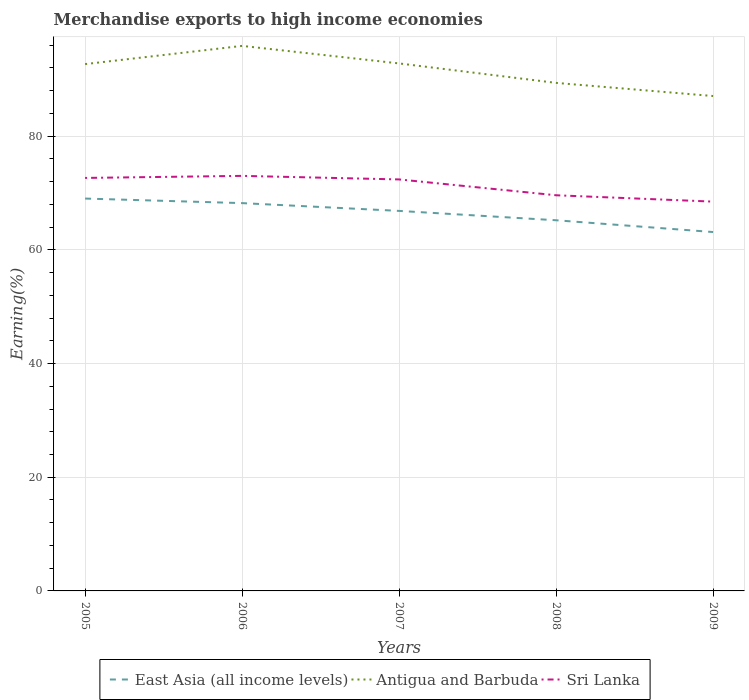Does the line corresponding to East Asia (all income levels) intersect with the line corresponding to Antigua and Barbuda?
Ensure brevity in your answer.  No. Across all years, what is the maximum percentage of amount earned from merchandise exports in East Asia (all income levels)?
Your answer should be compact. 63.13. In which year was the percentage of amount earned from merchandise exports in Antigua and Barbuda maximum?
Your answer should be very brief. 2009. What is the total percentage of amount earned from merchandise exports in Sri Lanka in the graph?
Provide a succinct answer. 4.17. What is the difference between the highest and the second highest percentage of amount earned from merchandise exports in Sri Lanka?
Provide a succinct answer. 4.53. What is the difference between the highest and the lowest percentage of amount earned from merchandise exports in Antigua and Barbuda?
Give a very brief answer. 3. Is the percentage of amount earned from merchandise exports in Sri Lanka strictly greater than the percentage of amount earned from merchandise exports in Antigua and Barbuda over the years?
Provide a succinct answer. Yes. How many years are there in the graph?
Keep it short and to the point. 5. Are the values on the major ticks of Y-axis written in scientific E-notation?
Offer a very short reply. No. How are the legend labels stacked?
Keep it short and to the point. Horizontal. What is the title of the graph?
Ensure brevity in your answer.  Merchandise exports to high income economies. What is the label or title of the X-axis?
Make the answer very short. Years. What is the label or title of the Y-axis?
Ensure brevity in your answer.  Earning(%). What is the Earning(%) in East Asia (all income levels) in 2005?
Offer a terse response. 69.02. What is the Earning(%) in Antigua and Barbuda in 2005?
Provide a succinct answer. 92.67. What is the Earning(%) in Sri Lanka in 2005?
Your response must be concise. 72.65. What is the Earning(%) in East Asia (all income levels) in 2006?
Offer a terse response. 68.22. What is the Earning(%) in Antigua and Barbuda in 2006?
Your answer should be very brief. 95.88. What is the Earning(%) in Sri Lanka in 2006?
Provide a succinct answer. 73.01. What is the Earning(%) in East Asia (all income levels) in 2007?
Keep it short and to the point. 66.85. What is the Earning(%) in Antigua and Barbuda in 2007?
Your answer should be very brief. 92.79. What is the Earning(%) in Sri Lanka in 2007?
Provide a short and direct response. 72.39. What is the Earning(%) of East Asia (all income levels) in 2008?
Give a very brief answer. 65.2. What is the Earning(%) of Antigua and Barbuda in 2008?
Keep it short and to the point. 89.37. What is the Earning(%) of Sri Lanka in 2008?
Make the answer very short. 69.6. What is the Earning(%) in East Asia (all income levels) in 2009?
Offer a terse response. 63.13. What is the Earning(%) in Antigua and Barbuda in 2009?
Offer a very short reply. 87.06. What is the Earning(%) of Sri Lanka in 2009?
Offer a terse response. 68.48. Across all years, what is the maximum Earning(%) in East Asia (all income levels)?
Your response must be concise. 69.02. Across all years, what is the maximum Earning(%) of Antigua and Barbuda?
Provide a short and direct response. 95.88. Across all years, what is the maximum Earning(%) in Sri Lanka?
Your answer should be very brief. 73.01. Across all years, what is the minimum Earning(%) in East Asia (all income levels)?
Ensure brevity in your answer.  63.13. Across all years, what is the minimum Earning(%) of Antigua and Barbuda?
Your response must be concise. 87.06. Across all years, what is the minimum Earning(%) of Sri Lanka?
Make the answer very short. 68.48. What is the total Earning(%) in East Asia (all income levels) in the graph?
Keep it short and to the point. 332.43. What is the total Earning(%) of Antigua and Barbuda in the graph?
Your answer should be very brief. 457.77. What is the total Earning(%) in Sri Lanka in the graph?
Your answer should be compact. 356.13. What is the difference between the Earning(%) of East Asia (all income levels) in 2005 and that in 2006?
Ensure brevity in your answer.  0.8. What is the difference between the Earning(%) in Antigua and Barbuda in 2005 and that in 2006?
Give a very brief answer. -3.21. What is the difference between the Earning(%) of Sri Lanka in 2005 and that in 2006?
Offer a terse response. -0.36. What is the difference between the Earning(%) of East Asia (all income levels) in 2005 and that in 2007?
Ensure brevity in your answer.  2.17. What is the difference between the Earning(%) of Antigua and Barbuda in 2005 and that in 2007?
Make the answer very short. -0.12. What is the difference between the Earning(%) of Sri Lanka in 2005 and that in 2007?
Provide a succinct answer. 0.26. What is the difference between the Earning(%) in East Asia (all income levels) in 2005 and that in 2008?
Your answer should be very brief. 3.82. What is the difference between the Earning(%) of Antigua and Barbuda in 2005 and that in 2008?
Ensure brevity in your answer.  3.3. What is the difference between the Earning(%) of Sri Lanka in 2005 and that in 2008?
Your answer should be very brief. 3.05. What is the difference between the Earning(%) in East Asia (all income levels) in 2005 and that in 2009?
Make the answer very short. 5.89. What is the difference between the Earning(%) of Antigua and Barbuda in 2005 and that in 2009?
Your answer should be very brief. 5.62. What is the difference between the Earning(%) of Sri Lanka in 2005 and that in 2009?
Your response must be concise. 4.17. What is the difference between the Earning(%) in East Asia (all income levels) in 2006 and that in 2007?
Make the answer very short. 1.37. What is the difference between the Earning(%) in Antigua and Barbuda in 2006 and that in 2007?
Your answer should be compact. 3.09. What is the difference between the Earning(%) in Sri Lanka in 2006 and that in 2007?
Make the answer very short. 0.63. What is the difference between the Earning(%) in East Asia (all income levels) in 2006 and that in 2008?
Your answer should be compact. 3.02. What is the difference between the Earning(%) in Antigua and Barbuda in 2006 and that in 2008?
Give a very brief answer. 6.51. What is the difference between the Earning(%) in Sri Lanka in 2006 and that in 2008?
Offer a terse response. 3.41. What is the difference between the Earning(%) in East Asia (all income levels) in 2006 and that in 2009?
Your answer should be compact. 5.09. What is the difference between the Earning(%) in Antigua and Barbuda in 2006 and that in 2009?
Offer a very short reply. 8.82. What is the difference between the Earning(%) of Sri Lanka in 2006 and that in 2009?
Offer a very short reply. 4.53. What is the difference between the Earning(%) of East Asia (all income levels) in 2007 and that in 2008?
Keep it short and to the point. 1.65. What is the difference between the Earning(%) of Antigua and Barbuda in 2007 and that in 2008?
Provide a succinct answer. 3.42. What is the difference between the Earning(%) in Sri Lanka in 2007 and that in 2008?
Your answer should be compact. 2.79. What is the difference between the Earning(%) in East Asia (all income levels) in 2007 and that in 2009?
Your response must be concise. 3.72. What is the difference between the Earning(%) of Antigua and Barbuda in 2007 and that in 2009?
Your answer should be compact. 5.73. What is the difference between the Earning(%) of Sri Lanka in 2007 and that in 2009?
Provide a succinct answer. 3.9. What is the difference between the Earning(%) of East Asia (all income levels) in 2008 and that in 2009?
Your answer should be very brief. 2.07. What is the difference between the Earning(%) of Antigua and Barbuda in 2008 and that in 2009?
Offer a terse response. 2.31. What is the difference between the Earning(%) of Sri Lanka in 2008 and that in 2009?
Your answer should be very brief. 1.12. What is the difference between the Earning(%) in East Asia (all income levels) in 2005 and the Earning(%) in Antigua and Barbuda in 2006?
Keep it short and to the point. -26.86. What is the difference between the Earning(%) of East Asia (all income levels) in 2005 and the Earning(%) of Sri Lanka in 2006?
Your answer should be very brief. -3.99. What is the difference between the Earning(%) in Antigua and Barbuda in 2005 and the Earning(%) in Sri Lanka in 2006?
Keep it short and to the point. 19.66. What is the difference between the Earning(%) in East Asia (all income levels) in 2005 and the Earning(%) in Antigua and Barbuda in 2007?
Provide a short and direct response. -23.77. What is the difference between the Earning(%) in East Asia (all income levels) in 2005 and the Earning(%) in Sri Lanka in 2007?
Your response must be concise. -3.36. What is the difference between the Earning(%) in Antigua and Barbuda in 2005 and the Earning(%) in Sri Lanka in 2007?
Offer a very short reply. 20.29. What is the difference between the Earning(%) in East Asia (all income levels) in 2005 and the Earning(%) in Antigua and Barbuda in 2008?
Provide a succinct answer. -20.35. What is the difference between the Earning(%) in East Asia (all income levels) in 2005 and the Earning(%) in Sri Lanka in 2008?
Keep it short and to the point. -0.58. What is the difference between the Earning(%) of Antigua and Barbuda in 2005 and the Earning(%) of Sri Lanka in 2008?
Your response must be concise. 23.07. What is the difference between the Earning(%) in East Asia (all income levels) in 2005 and the Earning(%) in Antigua and Barbuda in 2009?
Offer a very short reply. -18.04. What is the difference between the Earning(%) of East Asia (all income levels) in 2005 and the Earning(%) of Sri Lanka in 2009?
Provide a short and direct response. 0.54. What is the difference between the Earning(%) in Antigua and Barbuda in 2005 and the Earning(%) in Sri Lanka in 2009?
Provide a short and direct response. 24.19. What is the difference between the Earning(%) in East Asia (all income levels) in 2006 and the Earning(%) in Antigua and Barbuda in 2007?
Offer a very short reply. -24.57. What is the difference between the Earning(%) of East Asia (all income levels) in 2006 and the Earning(%) of Sri Lanka in 2007?
Ensure brevity in your answer.  -4.17. What is the difference between the Earning(%) in Antigua and Barbuda in 2006 and the Earning(%) in Sri Lanka in 2007?
Your response must be concise. 23.49. What is the difference between the Earning(%) in East Asia (all income levels) in 2006 and the Earning(%) in Antigua and Barbuda in 2008?
Offer a very short reply. -21.15. What is the difference between the Earning(%) in East Asia (all income levels) in 2006 and the Earning(%) in Sri Lanka in 2008?
Your response must be concise. -1.38. What is the difference between the Earning(%) in Antigua and Barbuda in 2006 and the Earning(%) in Sri Lanka in 2008?
Give a very brief answer. 26.28. What is the difference between the Earning(%) of East Asia (all income levels) in 2006 and the Earning(%) of Antigua and Barbuda in 2009?
Provide a short and direct response. -18.84. What is the difference between the Earning(%) of East Asia (all income levels) in 2006 and the Earning(%) of Sri Lanka in 2009?
Keep it short and to the point. -0.26. What is the difference between the Earning(%) in Antigua and Barbuda in 2006 and the Earning(%) in Sri Lanka in 2009?
Make the answer very short. 27.39. What is the difference between the Earning(%) in East Asia (all income levels) in 2007 and the Earning(%) in Antigua and Barbuda in 2008?
Your response must be concise. -22.52. What is the difference between the Earning(%) in East Asia (all income levels) in 2007 and the Earning(%) in Sri Lanka in 2008?
Your answer should be compact. -2.75. What is the difference between the Earning(%) in Antigua and Barbuda in 2007 and the Earning(%) in Sri Lanka in 2008?
Offer a very short reply. 23.19. What is the difference between the Earning(%) in East Asia (all income levels) in 2007 and the Earning(%) in Antigua and Barbuda in 2009?
Keep it short and to the point. -20.21. What is the difference between the Earning(%) in East Asia (all income levels) in 2007 and the Earning(%) in Sri Lanka in 2009?
Your answer should be compact. -1.63. What is the difference between the Earning(%) of Antigua and Barbuda in 2007 and the Earning(%) of Sri Lanka in 2009?
Make the answer very short. 24.31. What is the difference between the Earning(%) in East Asia (all income levels) in 2008 and the Earning(%) in Antigua and Barbuda in 2009?
Make the answer very short. -21.85. What is the difference between the Earning(%) in East Asia (all income levels) in 2008 and the Earning(%) in Sri Lanka in 2009?
Your answer should be compact. -3.28. What is the difference between the Earning(%) in Antigua and Barbuda in 2008 and the Earning(%) in Sri Lanka in 2009?
Ensure brevity in your answer.  20.89. What is the average Earning(%) of East Asia (all income levels) per year?
Give a very brief answer. 66.48. What is the average Earning(%) in Antigua and Barbuda per year?
Make the answer very short. 91.55. What is the average Earning(%) in Sri Lanka per year?
Offer a terse response. 71.23. In the year 2005, what is the difference between the Earning(%) in East Asia (all income levels) and Earning(%) in Antigua and Barbuda?
Offer a terse response. -23.65. In the year 2005, what is the difference between the Earning(%) of East Asia (all income levels) and Earning(%) of Sri Lanka?
Keep it short and to the point. -3.63. In the year 2005, what is the difference between the Earning(%) of Antigua and Barbuda and Earning(%) of Sri Lanka?
Make the answer very short. 20.02. In the year 2006, what is the difference between the Earning(%) of East Asia (all income levels) and Earning(%) of Antigua and Barbuda?
Your answer should be very brief. -27.66. In the year 2006, what is the difference between the Earning(%) of East Asia (all income levels) and Earning(%) of Sri Lanka?
Provide a short and direct response. -4.79. In the year 2006, what is the difference between the Earning(%) in Antigua and Barbuda and Earning(%) in Sri Lanka?
Your answer should be very brief. 22.87. In the year 2007, what is the difference between the Earning(%) of East Asia (all income levels) and Earning(%) of Antigua and Barbuda?
Your answer should be very brief. -25.94. In the year 2007, what is the difference between the Earning(%) of East Asia (all income levels) and Earning(%) of Sri Lanka?
Make the answer very short. -5.54. In the year 2007, what is the difference between the Earning(%) in Antigua and Barbuda and Earning(%) in Sri Lanka?
Your response must be concise. 20.41. In the year 2008, what is the difference between the Earning(%) of East Asia (all income levels) and Earning(%) of Antigua and Barbuda?
Keep it short and to the point. -24.17. In the year 2008, what is the difference between the Earning(%) of East Asia (all income levels) and Earning(%) of Sri Lanka?
Give a very brief answer. -4.4. In the year 2008, what is the difference between the Earning(%) in Antigua and Barbuda and Earning(%) in Sri Lanka?
Provide a succinct answer. 19.77. In the year 2009, what is the difference between the Earning(%) in East Asia (all income levels) and Earning(%) in Antigua and Barbuda?
Your answer should be very brief. -23.93. In the year 2009, what is the difference between the Earning(%) of East Asia (all income levels) and Earning(%) of Sri Lanka?
Offer a terse response. -5.35. In the year 2009, what is the difference between the Earning(%) of Antigua and Barbuda and Earning(%) of Sri Lanka?
Make the answer very short. 18.57. What is the ratio of the Earning(%) in East Asia (all income levels) in 2005 to that in 2006?
Keep it short and to the point. 1.01. What is the ratio of the Earning(%) of Antigua and Barbuda in 2005 to that in 2006?
Keep it short and to the point. 0.97. What is the ratio of the Earning(%) in Sri Lanka in 2005 to that in 2006?
Offer a very short reply. 0.99. What is the ratio of the Earning(%) in East Asia (all income levels) in 2005 to that in 2007?
Your response must be concise. 1.03. What is the ratio of the Earning(%) of Antigua and Barbuda in 2005 to that in 2007?
Your answer should be very brief. 1. What is the ratio of the Earning(%) of East Asia (all income levels) in 2005 to that in 2008?
Make the answer very short. 1.06. What is the ratio of the Earning(%) of Sri Lanka in 2005 to that in 2008?
Your response must be concise. 1.04. What is the ratio of the Earning(%) of East Asia (all income levels) in 2005 to that in 2009?
Your answer should be compact. 1.09. What is the ratio of the Earning(%) in Antigua and Barbuda in 2005 to that in 2009?
Your answer should be very brief. 1.06. What is the ratio of the Earning(%) in Sri Lanka in 2005 to that in 2009?
Make the answer very short. 1.06. What is the ratio of the Earning(%) in East Asia (all income levels) in 2006 to that in 2007?
Your response must be concise. 1.02. What is the ratio of the Earning(%) in Sri Lanka in 2006 to that in 2007?
Your answer should be compact. 1.01. What is the ratio of the Earning(%) of East Asia (all income levels) in 2006 to that in 2008?
Provide a short and direct response. 1.05. What is the ratio of the Earning(%) of Antigua and Barbuda in 2006 to that in 2008?
Your answer should be compact. 1.07. What is the ratio of the Earning(%) of Sri Lanka in 2006 to that in 2008?
Make the answer very short. 1.05. What is the ratio of the Earning(%) in East Asia (all income levels) in 2006 to that in 2009?
Give a very brief answer. 1.08. What is the ratio of the Earning(%) of Antigua and Barbuda in 2006 to that in 2009?
Give a very brief answer. 1.1. What is the ratio of the Earning(%) of Sri Lanka in 2006 to that in 2009?
Keep it short and to the point. 1.07. What is the ratio of the Earning(%) in East Asia (all income levels) in 2007 to that in 2008?
Give a very brief answer. 1.03. What is the ratio of the Earning(%) of Antigua and Barbuda in 2007 to that in 2008?
Offer a terse response. 1.04. What is the ratio of the Earning(%) in Sri Lanka in 2007 to that in 2008?
Provide a short and direct response. 1.04. What is the ratio of the Earning(%) in East Asia (all income levels) in 2007 to that in 2009?
Your answer should be very brief. 1.06. What is the ratio of the Earning(%) of Antigua and Barbuda in 2007 to that in 2009?
Ensure brevity in your answer.  1.07. What is the ratio of the Earning(%) in Sri Lanka in 2007 to that in 2009?
Your answer should be very brief. 1.06. What is the ratio of the Earning(%) of East Asia (all income levels) in 2008 to that in 2009?
Your answer should be very brief. 1.03. What is the ratio of the Earning(%) in Antigua and Barbuda in 2008 to that in 2009?
Give a very brief answer. 1.03. What is the ratio of the Earning(%) in Sri Lanka in 2008 to that in 2009?
Offer a very short reply. 1.02. What is the difference between the highest and the second highest Earning(%) in East Asia (all income levels)?
Your answer should be very brief. 0.8. What is the difference between the highest and the second highest Earning(%) of Antigua and Barbuda?
Your answer should be compact. 3.09. What is the difference between the highest and the second highest Earning(%) of Sri Lanka?
Provide a succinct answer. 0.36. What is the difference between the highest and the lowest Earning(%) in East Asia (all income levels)?
Give a very brief answer. 5.89. What is the difference between the highest and the lowest Earning(%) in Antigua and Barbuda?
Provide a short and direct response. 8.82. What is the difference between the highest and the lowest Earning(%) in Sri Lanka?
Offer a very short reply. 4.53. 